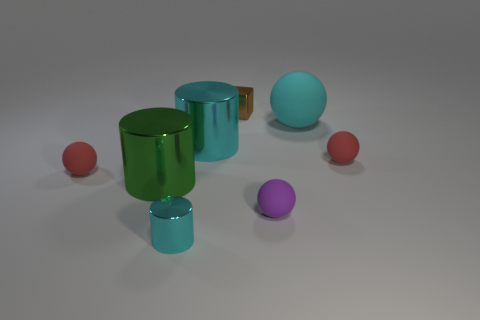Subtract all green balls. Subtract all purple cylinders. How many balls are left? 4 Add 1 large matte things. How many objects exist? 9 Subtract all cylinders. How many objects are left? 5 Add 4 purple rubber things. How many purple rubber things exist? 5 Subtract 0 green cubes. How many objects are left? 8 Subtract all cyan things. Subtract all small blocks. How many objects are left? 4 Add 6 small purple matte objects. How many small purple matte objects are left? 7 